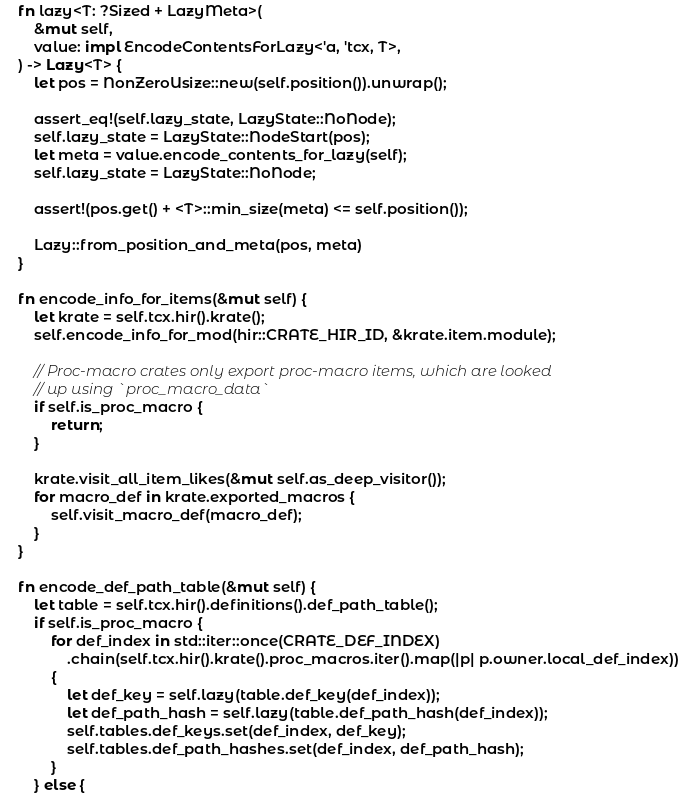Convert code to text. <code><loc_0><loc_0><loc_500><loc_500><_Rust_>
    fn lazy<T: ?Sized + LazyMeta>(
        &mut self,
        value: impl EncodeContentsForLazy<'a, 'tcx, T>,
    ) -> Lazy<T> {
        let pos = NonZeroUsize::new(self.position()).unwrap();

        assert_eq!(self.lazy_state, LazyState::NoNode);
        self.lazy_state = LazyState::NodeStart(pos);
        let meta = value.encode_contents_for_lazy(self);
        self.lazy_state = LazyState::NoNode;

        assert!(pos.get() + <T>::min_size(meta) <= self.position());

        Lazy::from_position_and_meta(pos, meta)
    }

    fn encode_info_for_items(&mut self) {
        let krate = self.tcx.hir().krate();
        self.encode_info_for_mod(hir::CRATE_HIR_ID, &krate.item.module);

        // Proc-macro crates only export proc-macro items, which are looked
        // up using `proc_macro_data`
        if self.is_proc_macro {
            return;
        }

        krate.visit_all_item_likes(&mut self.as_deep_visitor());
        for macro_def in krate.exported_macros {
            self.visit_macro_def(macro_def);
        }
    }

    fn encode_def_path_table(&mut self) {
        let table = self.tcx.hir().definitions().def_path_table();
        if self.is_proc_macro {
            for def_index in std::iter::once(CRATE_DEF_INDEX)
                .chain(self.tcx.hir().krate().proc_macros.iter().map(|p| p.owner.local_def_index))
            {
                let def_key = self.lazy(table.def_key(def_index));
                let def_path_hash = self.lazy(table.def_path_hash(def_index));
                self.tables.def_keys.set(def_index, def_key);
                self.tables.def_path_hashes.set(def_index, def_path_hash);
            }
        } else {</code> 